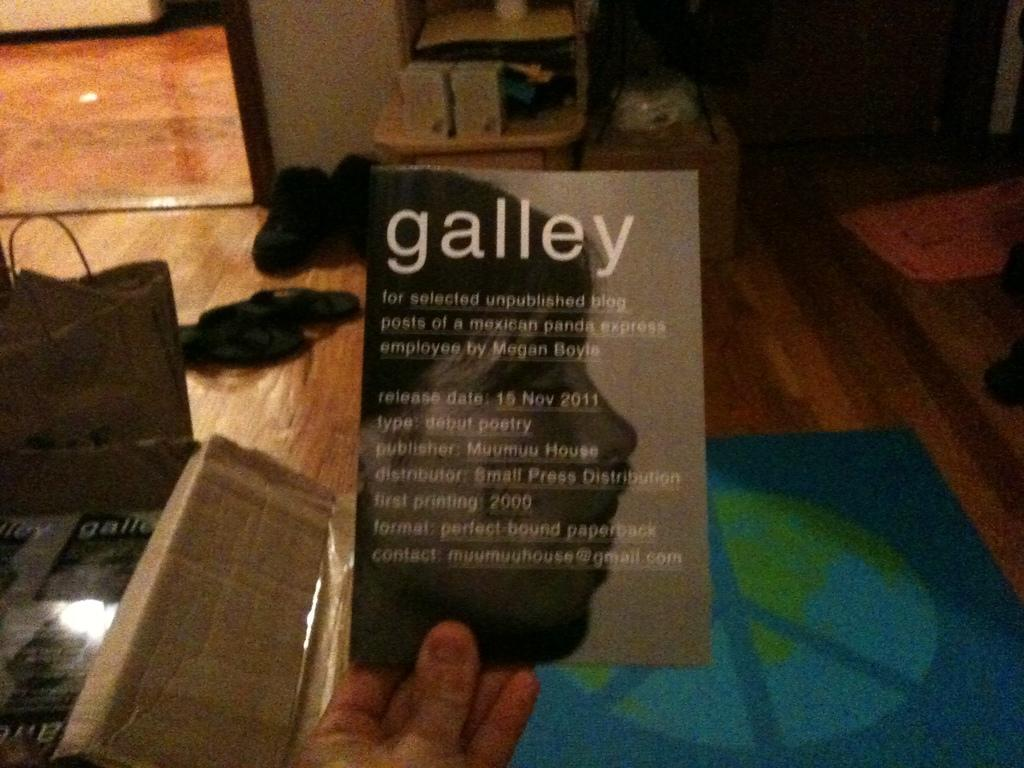What is on the floor in the room? There is a bag and footwear on the floor in the room. What is the person holding in the image? The person is holding a black card. What can be seen in the background of the room? There is a mirror and a basket in the background of the room. What type of fiction is the person reading in the image? There is no book or any indication of reading in the image. What reason might the person have for holding the black card? The reason for holding the black card cannot be determined from the image alone. What type of drug is present in the image? There is no drug present in the image. 